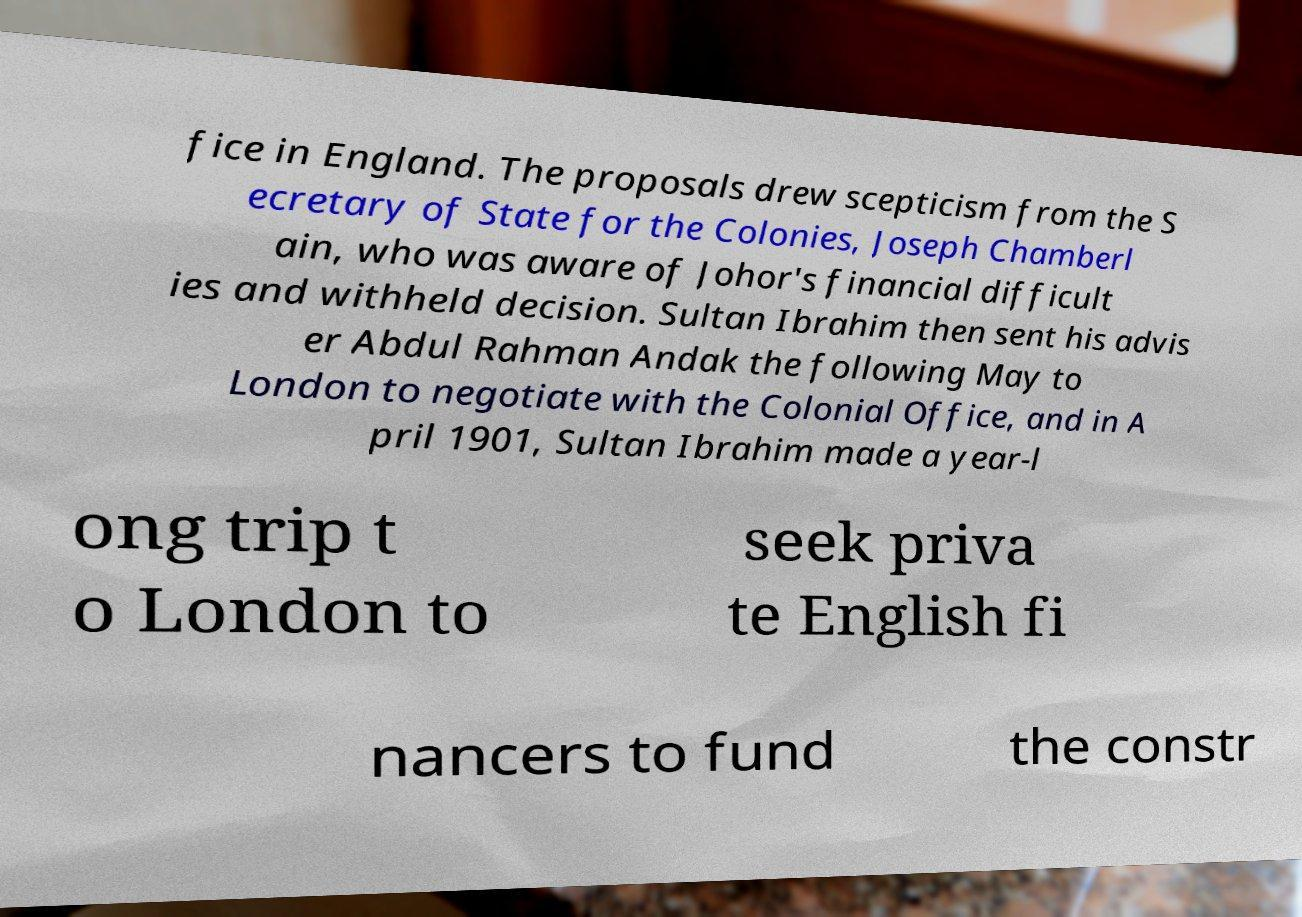Can you accurately transcribe the text from the provided image for me? fice in England. The proposals drew scepticism from the S ecretary of State for the Colonies, Joseph Chamberl ain, who was aware of Johor's financial difficult ies and withheld decision. Sultan Ibrahim then sent his advis er Abdul Rahman Andak the following May to London to negotiate with the Colonial Office, and in A pril 1901, Sultan Ibrahim made a year-l ong trip t o London to seek priva te English fi nancers to fund the constr 